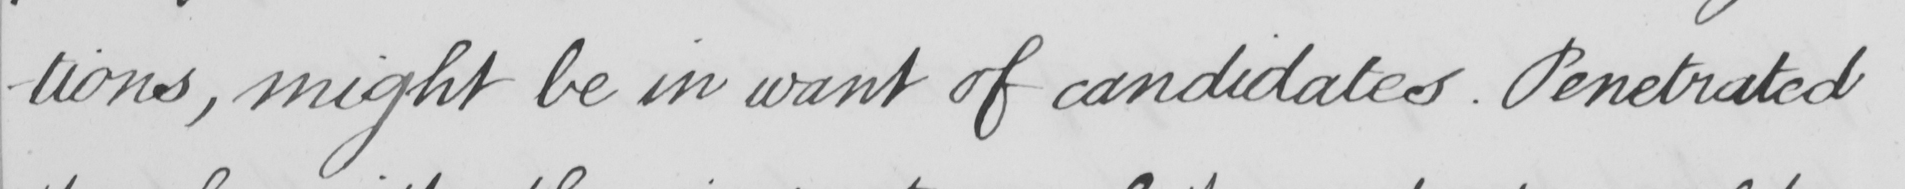What text is written in this handwritten line? -tions , might be in want of candidates . Penetrated 